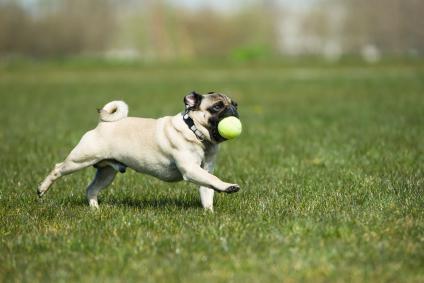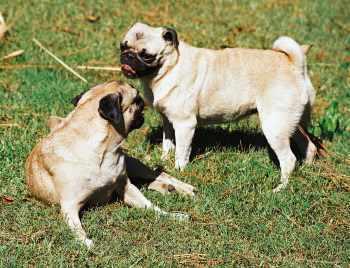The first image is the image on the left, the second image is the image on the right. Considering the images on both sides, is "There is no more than one dog in the left image." valid? Answer yes or no. Yes. The first image is the image on the left, the second image is the image on the right. For the images displayed, is the sentence "An image shows one pug with a toy ball of some type." factually correct? Answer yes or no. Yes. 